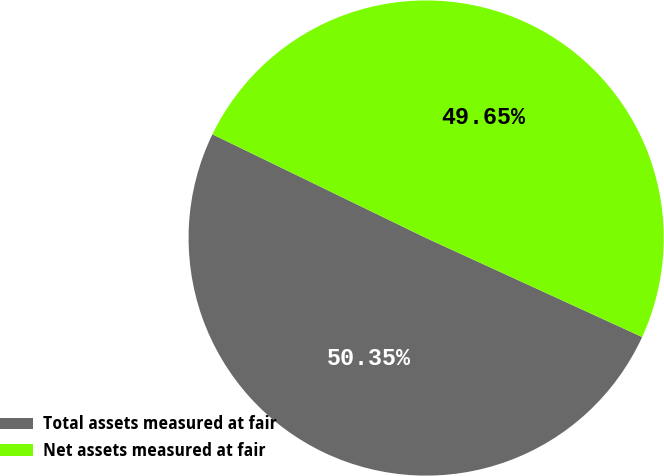<chart> <loc_0><loc_0><loc_500><loc_500><pie_chart><fcel>Total assets measured at fair<fcel>Net assets measured at fair<nl><fcel>50.35%<fcel>49.65%<nl></chart> 